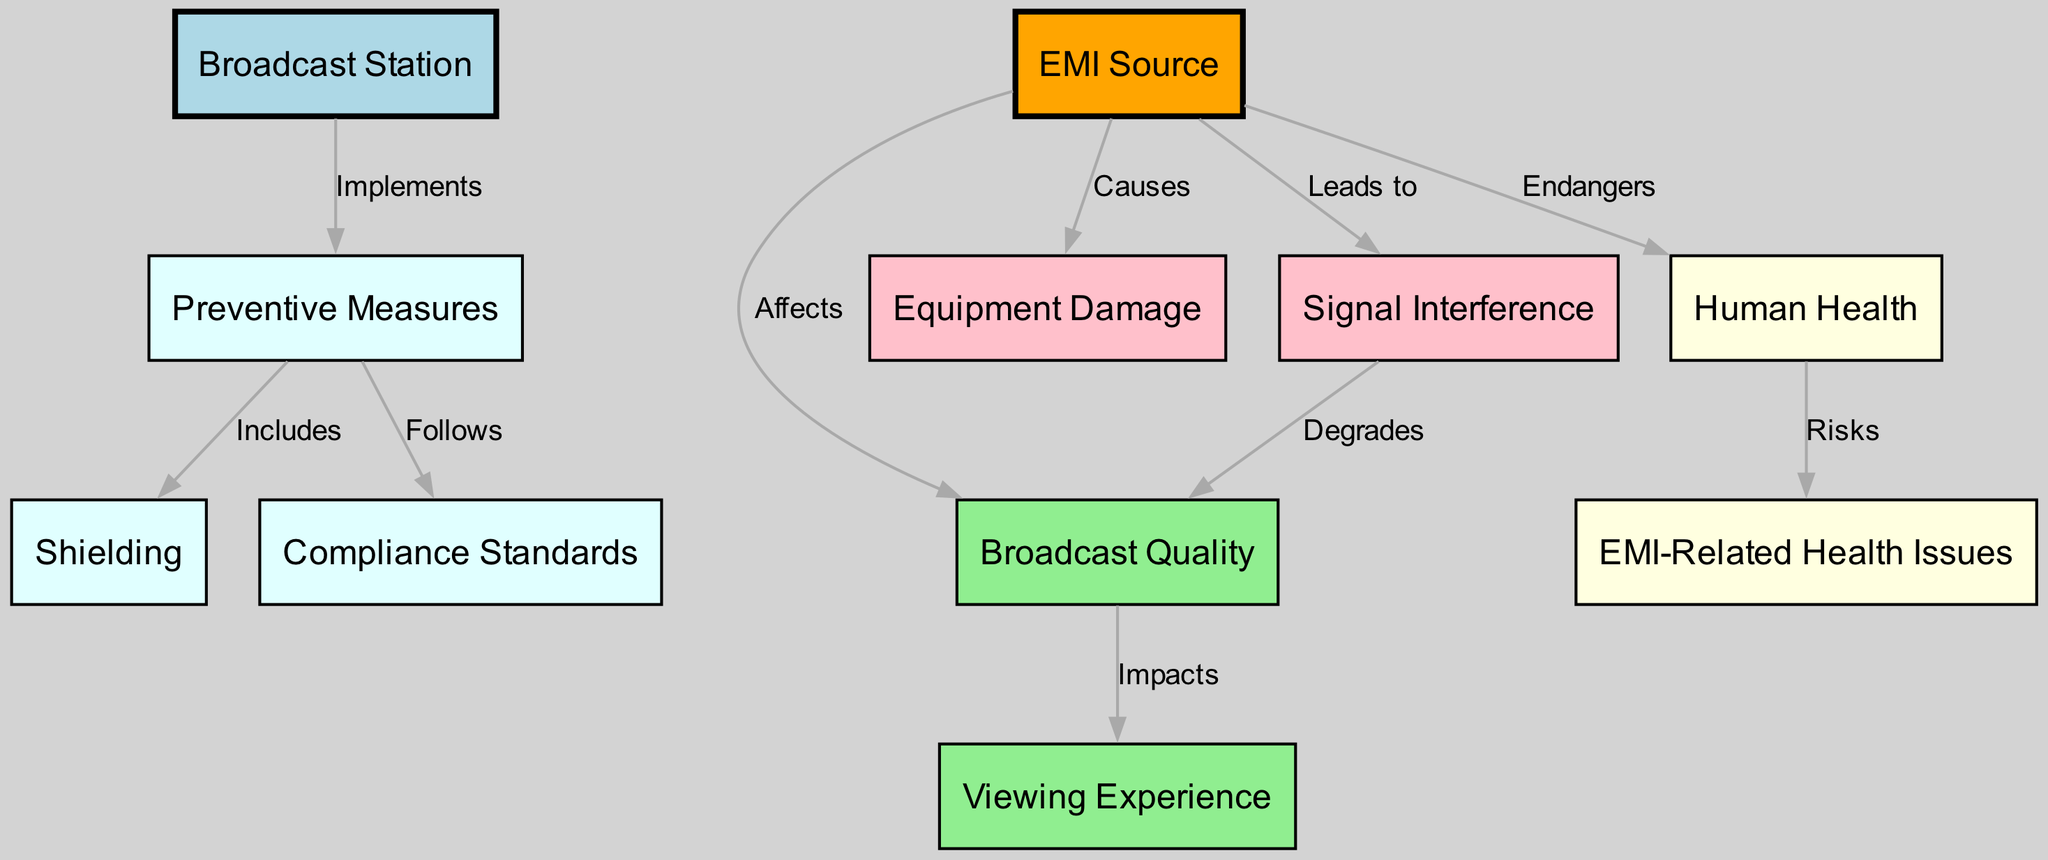What are the main components in this diagram? The diagram includes nodes such as Broadcast Station, EMI Source, Broadcast Quality, Equipment Damage, Signal Interference, Viewing Experience, Human Health, EMI-Related Health Issues, Preventive Measures, Shielding, and Compliance Standards.
Answer: Broadcast Station, EMI Source, Broadcast Quality, Equipment Damage, Signal Interference, Viewing Experience, Human Health, EMI-Related Health Issues, Preventive Measures, Shielding, Compliance Standards How many edges are in the diagram? By counting the number of relationships (edges) connecting the nodes, we find there are a total of 10 edges demonstrated in the diagram.
Answer: 10 What effect does the EMI Source have on Broadcast Quality? The edge connecting EMI Source to Broadcast Quality indicates that the EMI Source "Affects" the Broadcast Quality, showing a direct impact.
Answer: Affects Which node is connected to Equipment Damage? The diagram shows that Equipment Damage is directly caused by the EMI Source, as indicated by their connecting edge labeled "Causes."
Answer: EMI Source What are the Preventive Measures illustrated in the diagram? The diagram has nodes under Preventive Measures including Shielding and Compliance Standards, indicating the types of measures that can be implemented.
Answer: Shielding, Compliance Standards How does Signal Interference impact Broadcast Quality? The diagram indicates that Signal Interference "Degrades" Broadcast Quality, suggesting a negative influence on the quality of the broadcast.
Answer: Degrades What is the relationship between Human Health and EMI-Related Health Issues? The diagram specifies that Human Health "Risks" EMI-Related Health Issues, showcasing a concerning connection between the two.
Answer: Risks What node does the Preventive Measures connect to in the diagram? The Preventive Measures node connects to the Broadcast Station, highlighting the station's role in implementing preventative strategies.
Answer: Broadcast Station What is the role of the Broadcast Station regarding Preventive Measures? The Broadcast Station "Implements" Preventive Measures, emphasizing its responsibility in ensuring broadcast quality and equipment safety.
Answer: Implements 